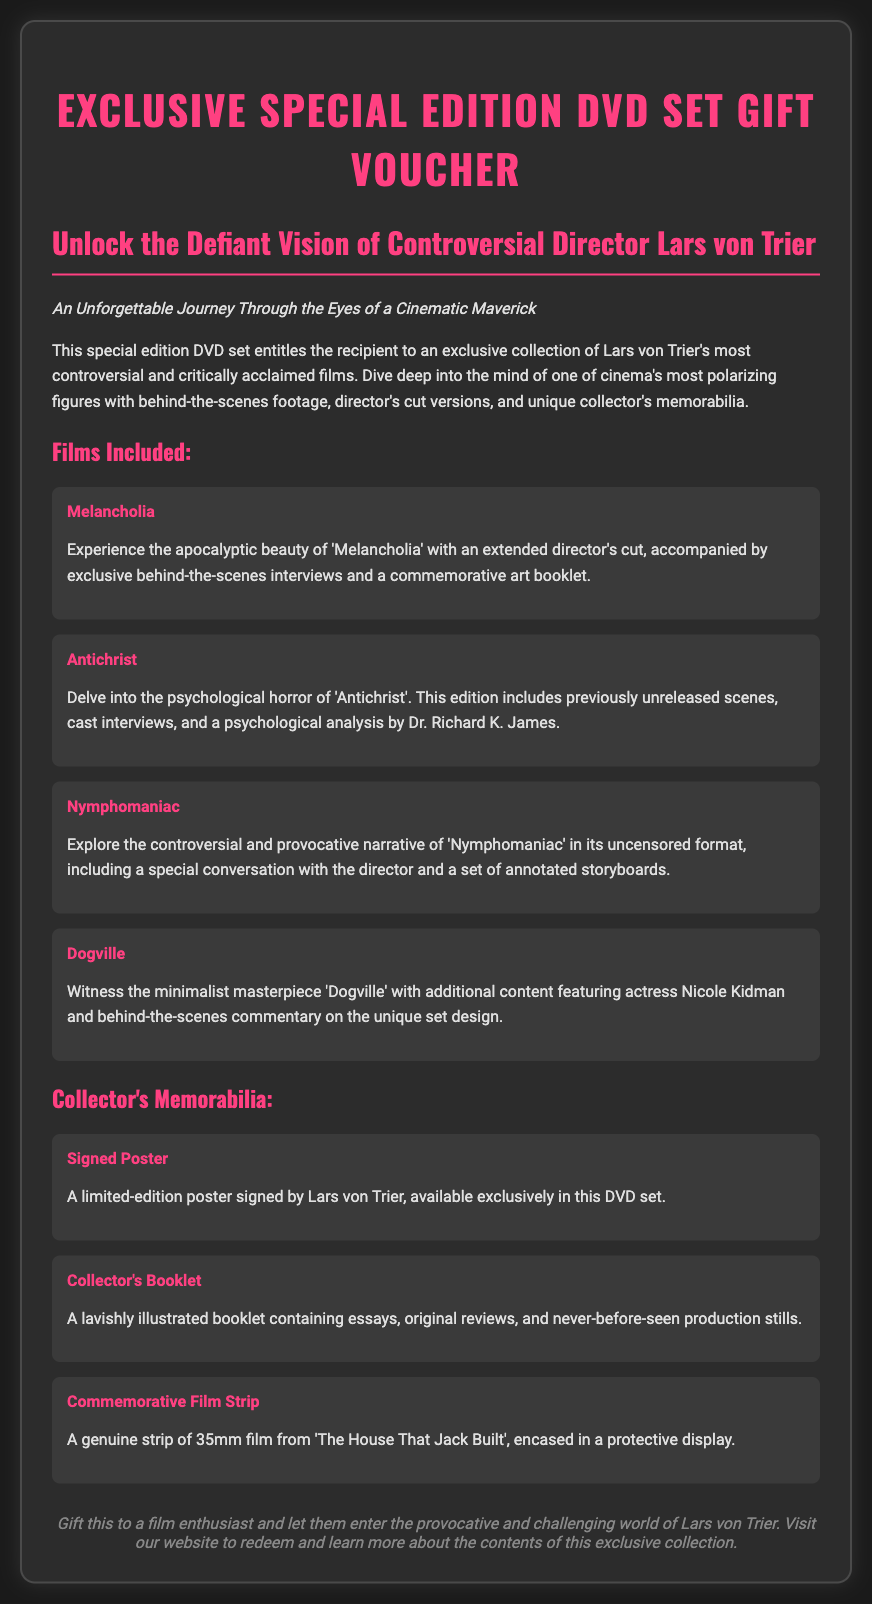what is the title of the voucher? The title of the voucher is displayed prominently at the top of the document.
Answer: Exclusive Special Edition DVD Set Gift Voucher who is the director featured in this special edition DVD set? The document specifies the director associated with the films in the collection.
Answer: Lars von Trier how many films are included in the DVD set? The document lists the films under a specific section that indicates the number of titles.
Answer: Four what is included with the film 'Melancholia'? The description of the film outlines the extra features that come with it.
Answer: Extended director's cut, exclusive behind-the-scenes interviews, commemorative art booklet what type of memorabilia is included in the set? The document provides a list of collectible items, specifying different types of memorabilia.
Answer: Signed Poster which film is accompanied by a psychological analysis? The details for each film explain any unique extras included with them.
Answer: Antichrist what does the collector's booklet contain? The description of the collector's booklet lists what it includes.
Answer: Essays, original reviews, never-before-seen production stills what item is a strip of 35mm film from? The memorabilia list indicates the film from which the film strip originates.
Answer: The House That Jack Built who is the target recipient for this gift voucher? The final note in the document suggests a specific audience that would appreciate this gift.
Answer: Film enthusiast 